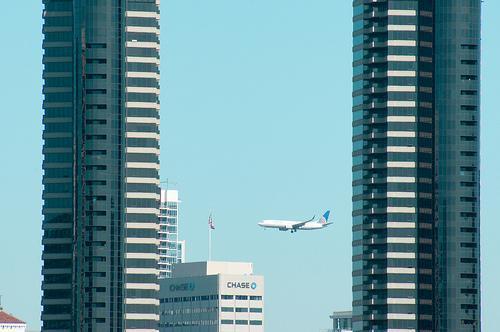How many airplanes are in the photo?
Give a very brief answer. 1. 